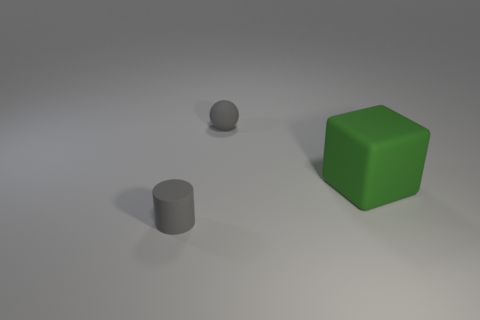Add 2 large blue shiny balls. How many objects exist? 5 Subtract all cylinders. How many objects are left? 2 Subtract all large matte cubes. Subtract all big objects. How many objects are left? 1 Add 1 big green matte objects. How many big green matte objects are left? 2 Add 3 large yellow matte balls. How many large yellow matte balls exist? 3 Subtract 0 cyan cylinders. How many objects are left? 3 